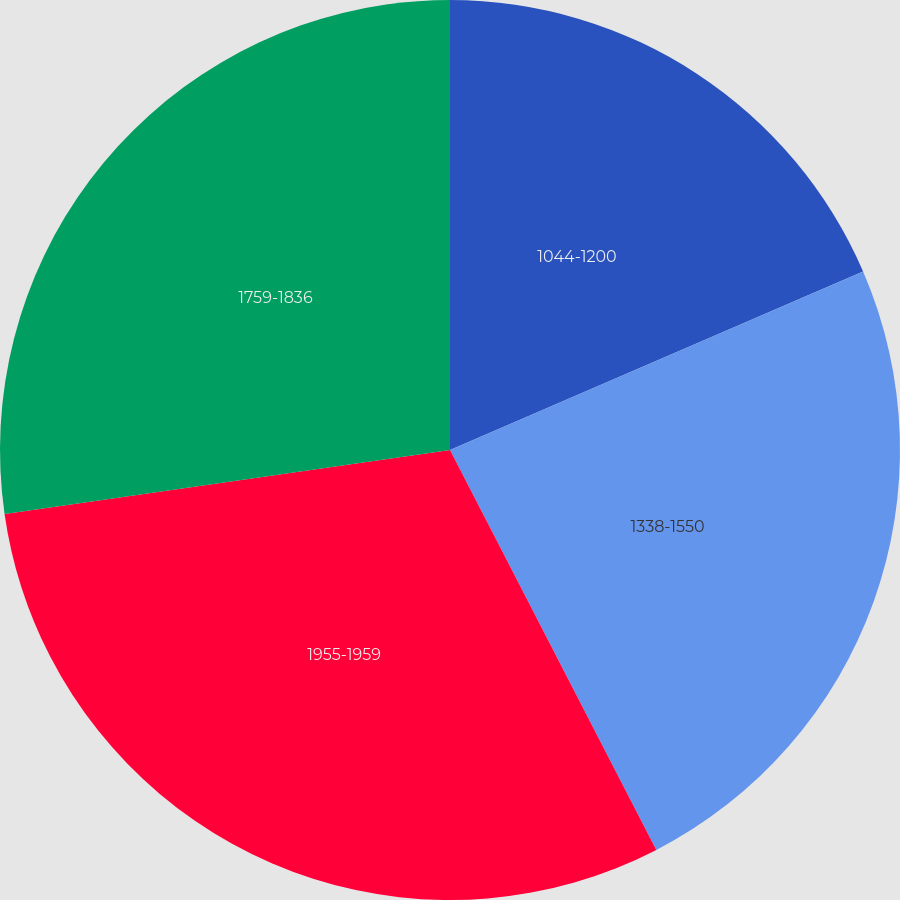Convert chart to OTSL. <chart><loc_0><loc_0><loc_500><loc_500><pie_chart><fcel>1044-1200<fcel>1338-1550<fcel>1955-1959<fcel>1759-1836<nl><fcel>18.51%<fcel>23.91%<fcel>30.31%<fcel>27.27%<nl></chart> 